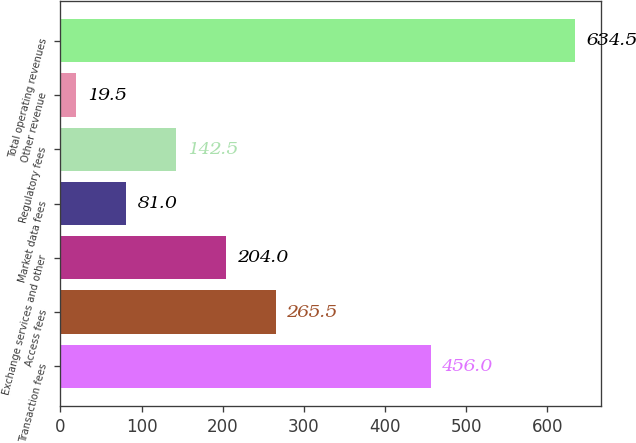Convert chart to OTSL. <chart><loc_0><loc_0><loc_500><loc_500><bar_chart><fcel>Transaction fees<fcel>Access fees<fcel>Exchange services and other<fcel>Market data fees<fcel>Regulatory fees<fcel>Other revenue<fcel>Total operating revenues<nl><fcel>456<fcel>265.5<fcel>204<fcel>81<fcel>142.5<fcel>19.5<fcel>634.5<nl></chart> 